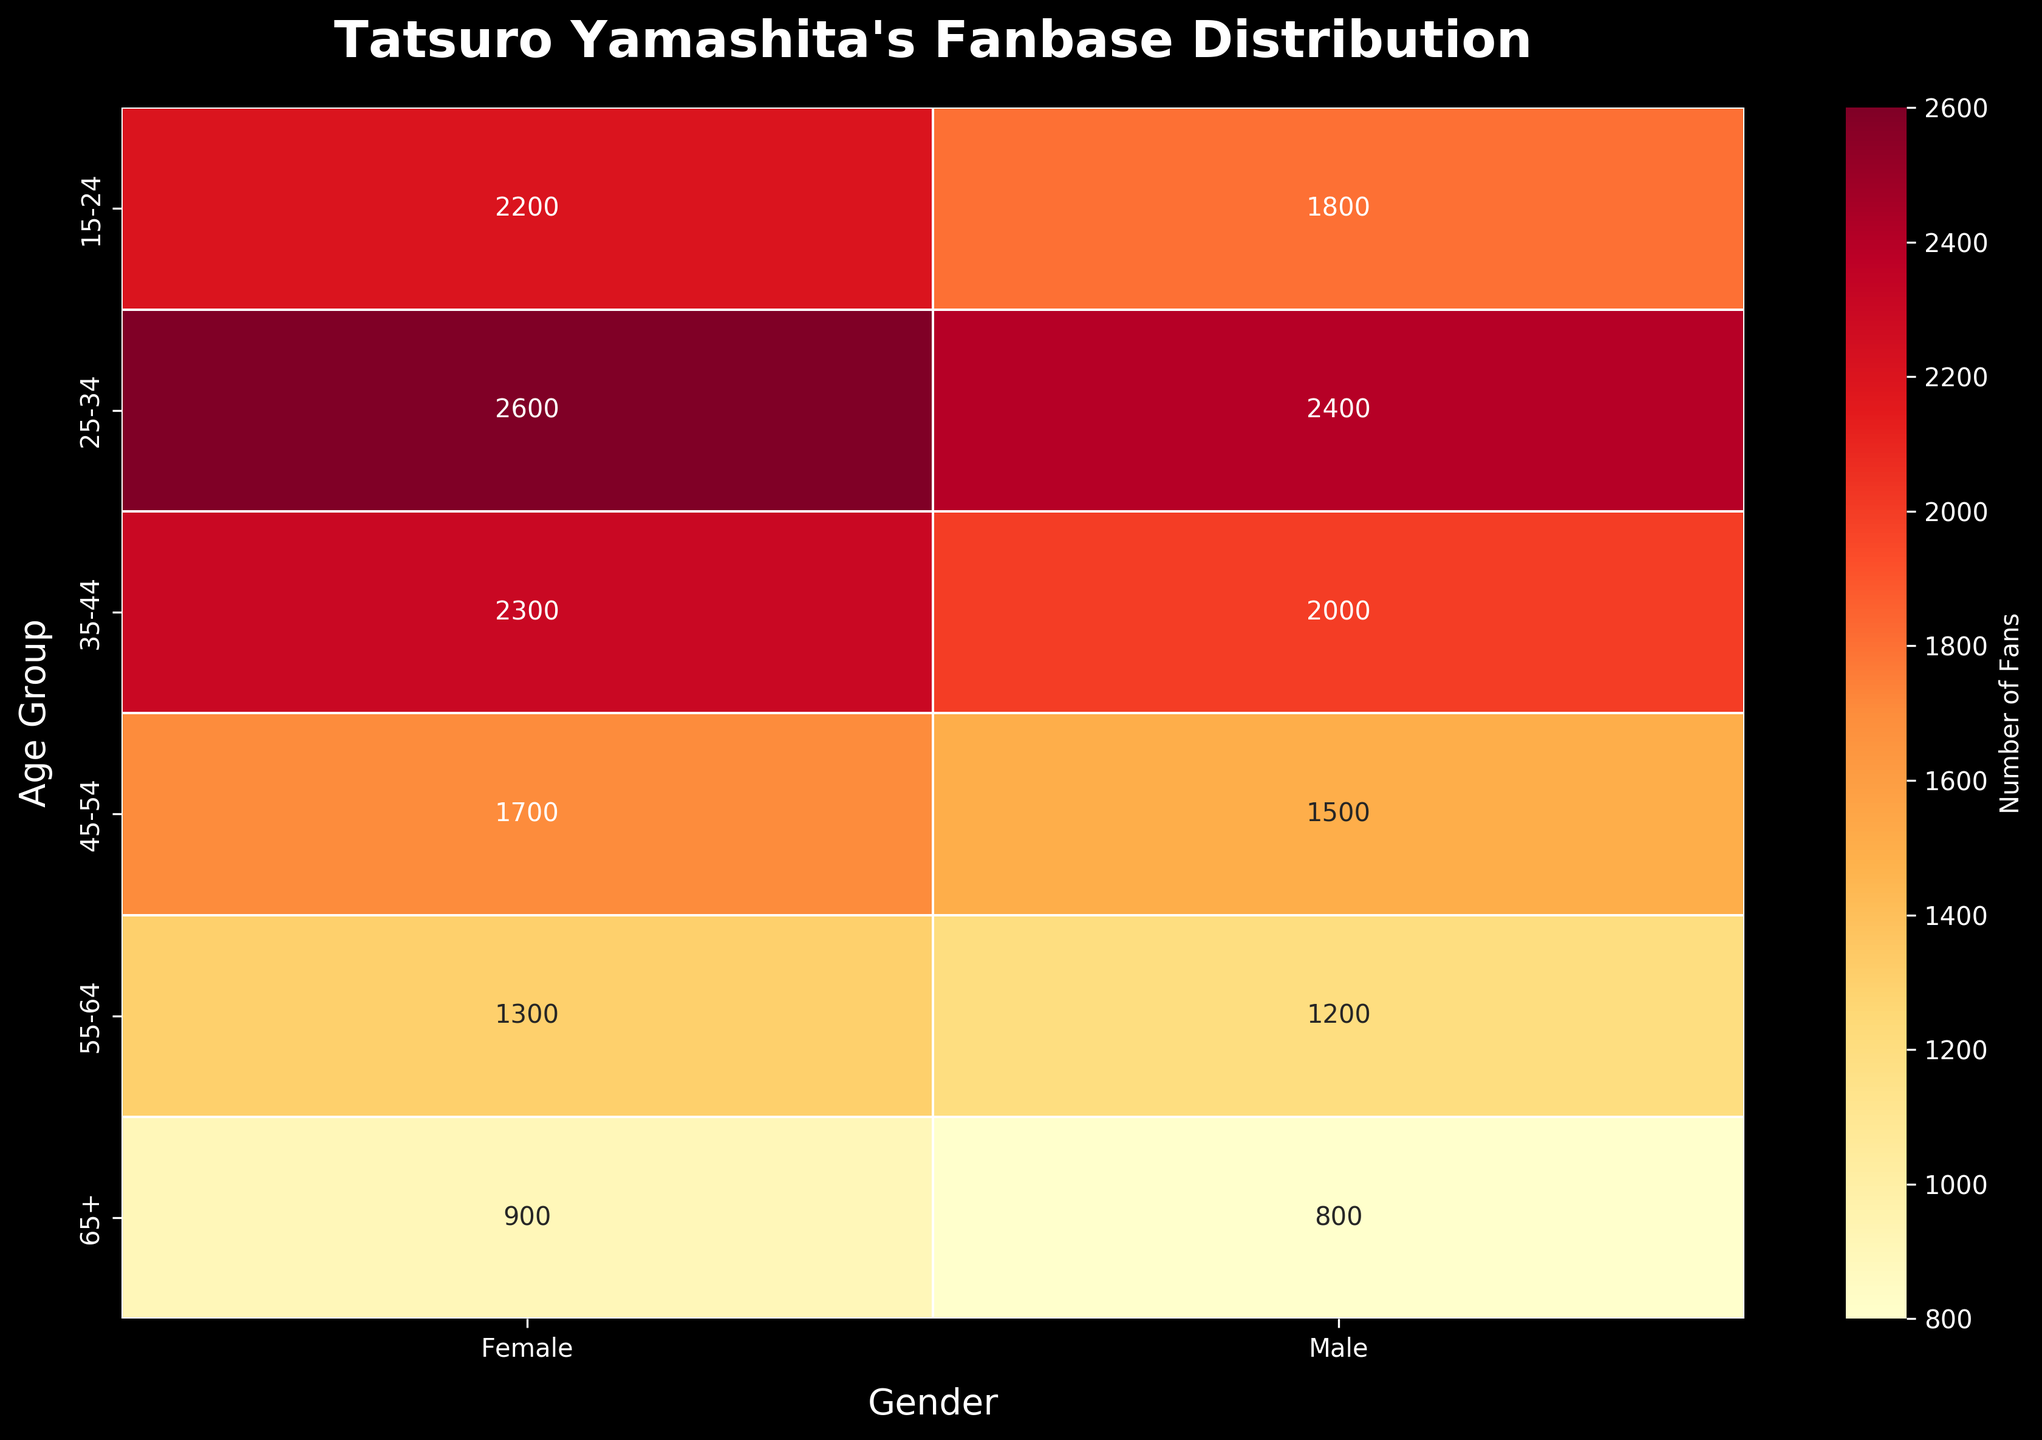What is the title of the heatmap? The title is displayed at the top of the heatmap and describes its content.
Answer: Tatsuro Yamashita's Fanbase Distribution Which age group has the highest number of female fans? By looking at the data values corresponding to females in each age group, we can identify the highest number.
Answer: 25-34 How many male fans are in the 35-44 age group? Locate the intersection of the '35-44' age group row and the 'Male' column to find this value.
Answer: 2000 What is the difference in the number of fans between males and females in the 15-24 age group? Subtract the number of male fans from the number of female fans in the 15-24 age group.
Answer: 400 Which gender has more fans in the 45-54 age group and by how much? Compare the counts of male and female fans in the 45-54 age group and then find their difference.
Answer: Female, by 200 What is the sum of all fans in the 55-64 age group? Add the number of male and female fans in the 55-64 age group.
Answer: 2500 Which age group has the smallest difference in the number of fans between genders? Calculate the differences for each age group and identify the smallest one.
Answer: 65+ Is the number of female fans always greater than the number of male fans across all age groups? Compare the count of female and male fans for each age group to see if this holds true.
Answer: Yes What's the average number of fans in the 25-34 age group? Sum the number of male and female fans in the 25-34 age group and divide by 2.
Answer: 2500 In which age group is the total number of fans the highest? Sum the male and female fans for each age group and identify the group with the highest total.
Answer: 25-34 